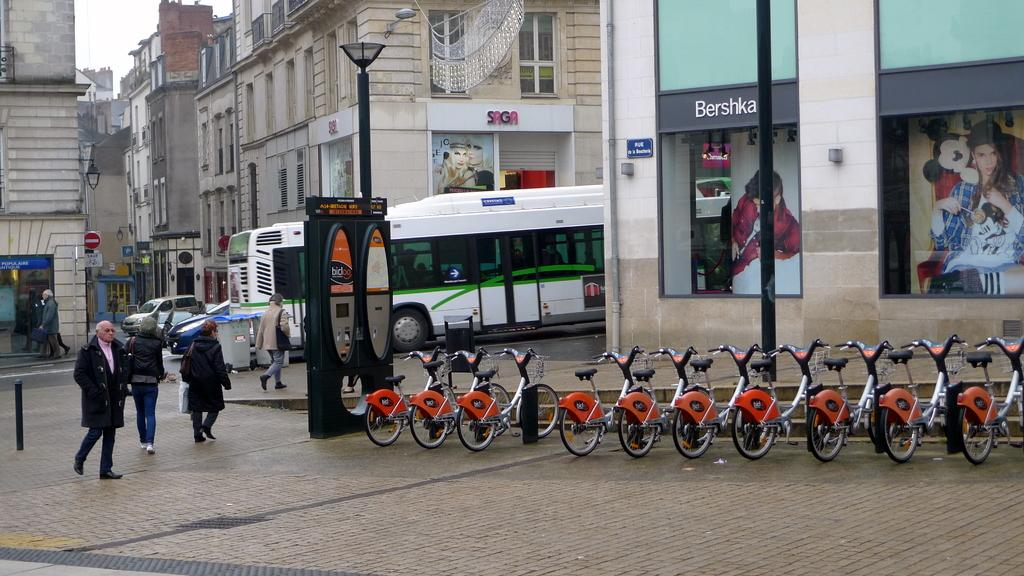Provide a one-sentence caption for the provided image. People walking towards a bus next to a building that says SAGA. 